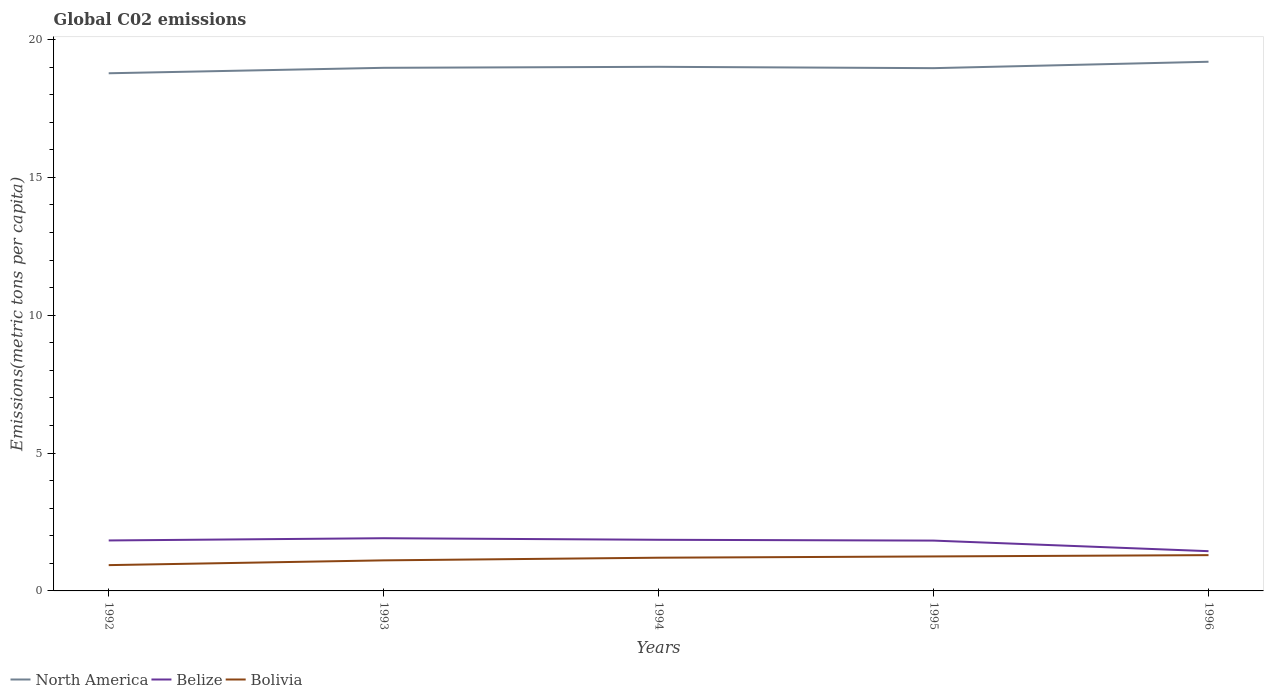How many different coloured lines are there?
Offer a terse response. 3. Does the line corresponding to North America intersect with the line corresponding to Bolivia?
Keep it short and to the point. No. Across all years, what is the maximum amount of CO2 emitted in in North America?
Your answer should be compact. 18.77. What is the total amount of CO2 emitted in in North America in the graph?
Ensure brevity in your answer.  -0.04. What is the difference between the highest and the second highest amount of CO2 emitted in in North America?
Give a very brief answer. 0.42. What is the difference between the highest and the lowest amount of CO2 emitted in in Bolivia?
Your response must be concise. 3. How many lines are there?
Ensure brevity in your answer.  3. What is the difference between two consecutive major ticks on the Y-axis?
Ensure brevity in your answer.  5. Does the graph contain any zero values?
Provide a short and direct response. No. Where does the legend appear in the graph?
Provide a succinct answer. Bottom left. How many legend labels are there?
Give a very brief answer. 3. What is the title of the graph?
Keep it short and to the point. Global C02 emissions. What is the label or title of the X-axis?
Make the answer very short. Years. What is the label or title of the Y-axis?
Offer a very short reply. Emissions(metric tons per capita). What is the Emissions(metric tons per capita) of North America in 1992?
Offer a very short reply. 18.77. What is the Emissions(metric tons per capita) of Belize in 1992?
Keep it short and to the point. 1.83. What is the Emissions(metric tons per capita) of Bolivia in 1992?
Your answer should be very brief. 0.94. What is the Emissions(metric tons per capita) in North America in 1993?
Ensure brevity in your answer.  18.97. What is the Emissions(metric tons per capita) of Belize in 1993?
Your response must be concise. 1.91. What is the Emissions(metric tons per capita) of Bolivia in 1993?
Your answer should be compact. 1.11. What is the Emissions(metric tons per capita) of North America in 1994?
Provide a short and direct response. 19.01. What is the Emissions(metric tons per capita) of Belize in 1994?
Offer a terse response. 1.85. What is the Emissions(metric tons per capita) in Bolivia in 1994?
Ensure brevity in your answer.  1.2. What is the Emissions(metric tons per capita) of North America in 1995?
Your response must be concise. 18.96. What is the Emissions(metric tons per capita) in Belize in 1995?
Make the answer very short. 1.82. What is the Emissions(metric tons per capita) in Bolivia in 1995?
Keep it short and to the point. 1.25. What is the Emissions(metric tons per capita) in North America in 1996?
Your answer should be compact. 19.19. What is the Emissions(metric tons per capita) in Belize in 1996?
Your response must be concise. 1.44. What is the Emissions(metric tons per capita) in Bolivia in 1996?
Keep it short and to the point. 1.3. Across all years, what is the maximum Emissions(metric tons per capita) in North America?
Your answer should be compact. 19.19. Across all years, what is the maximum Emissions(metric tons per capita) in Belize?
Make the answer very short. 1.91. Across all years, what is the maximum Emissions(metric tons per capita) in Bolivia?
Provide a succinct answer. 1.3. Across all years, what is the minimum Emissions(metric tons per capita) in North America?
Ensure brevity in your answer.  18.77. Across all years, what is the minimum Emissions(metric tons per capita) in Belize?
Ensure brevity in your answer.  1.44. Across all years, what is the minimum Emissions(metric tons per capita) in Bolivia?
Ensure brevity in your answer.  0.94. What is the total Emissions(metric tons per capita) in North America in the graph?
Offer a terse response. 94.9. What is the total Emissions(metric tons per capita) of Belize in the graph?
Your answer should be very brief. 8.86. What is the total Emissions(metric tons per capita) in Bolivia in the graph?
Ensure brevity in your answer.  5.8. What is the difference between the Emissions(metric tons per capita) of North America in 1992 and that in 1993?
Ensure brevity in your answer.  -0.2. What is the difference between the Emissions(metric tons per capita) of Belize in 1992 and that in 1993?
Offer a very short reply. -0.08. What is the difference between the Emissions(metric tons per capita) of Bolivia in 1992 and that in 1993?
Give a very brief answer. -0.17. What is the difference between the Emissions(metric tons per capita) of North America in 1992 and that in 1994?
Your answer should be compact. -0.23. What is the difference between the Emissions(metric tons per capita) of Belize in 1992 and that in 1994?
Give a very brief answer. -0.02. What is the difference between the Emissions(metric tons per capita) of Bolivia in 1992 and that in 1994?
Provide a succinct answer. -0.27. What is the difference between the Emissions(metric tons per capita) in North America in 1992 and that in 1995?
Ensure brevity in your answer.  -0.19. What is the difference between the Emissions(metric tons per capita) of Belize in 1992 and that in 1995?
Keep it short and to the point. 0.01. What is the difference between the Emissions(metric tons per capita) in Bolivia in 1992 and that in 1995?
Keep it short and to the point. -0.31. What is the difference between the Emissions(metric tons per capita) of North America in 1992 and that in 1996?
Your response must be concise. -0.42. What is the difference between the Emissions(metric tons per capita) in Belize in 1992 and that in 1996?
Offer a terse response. 0.39. What is the difference between the Emissions(metric tons per capita) of Bolivia in 1992 and that in 1996?
Give a very brief answer. -0.36. What is the difference between the Emissions(metric tons per capita) in North America in 1993 and that in 1994?
Provide a succinct answer. -0.04. What is the difference between the Emissions(metric tons per capita) of Belize in 1993 and that in 1994?
Provide a short and direct response. 0.06. What is the difference between the Emissions(metric tons per capita) of Bolivia in 1993 and that in 1994?
Give a very brief answer. -0.1. What is the difference between the Emissions(metric tons per capita) of North America in 1993 and that in 1995?
Your response must be concise. 0.01. What is the difference between the Emissions(metric tons per capita) in Belize in 1993 and that in 1995?
Make the answer very short. 0.09. What is the difference between the Emissions(metric tons per capita) of Bolivia in 1993 and that in 1995?
Give a very brief answer. -0.14. What is the difference between the Emissions(metric tons per capita) of North America in 1993 and that in 1996?
Offer a terse response. -0.22. What is the difference between the Emissions(metric tons per capita) of Belize in 1993 and that in 1996?
Your response must be concise. 0.47. What is the difference between the Emissions(metric tons per capita) of Bolivia in 1993 and that in 1996?
Give a very brief answer. -0.19. What is the difference between the Emissions(metric tons per capita) of North America in 1994 and that in 1995?
Your answer should be compact. 0.05. What is the difference between the Emissions(metric tons per capita) in Belize in 1994 and that in 1995?
Your answer should be compact. 0.03. What is the difference between the Emissions(metric tons per capita) in Bolivia in 1994 and that in 1995?
Ensure brevity in your answer.  -0.05. What is the difference between the Emissions(metric tons per capita) of North America in 1994 and that in 1996?
Keep it short and to the point. -0.18. What is the difference between the Emissions(metric tons per capita) of Belize in 1994 and that in 1996?
Provide a short and direct response. 0.41. What is the difference between the Emissions(metric tons per capita) of Bolivia in 1994 and that in 1996?
Your answer should be very brief. -0.09. What is the difference between the Emissions(metric tons per capita) in North America in 1995 and that in 1996?
Ensure brevity in your answer.  -0.23. What is the difference between the Emissions(metric tons per capita) of Belize in 1995 and that in 1996?
Keep it short and to the point. 0.38. What is the difference between the Emissions(metric tons per capita) in Bolivia in 1995 and that in 1996?
Give a very brief answer. -0.05. What is the difference between the Emissions(metric tons per capita) of North America in 1992 and the Emissions(metric tons per capita) of Belize in 1993?
Your response must be concise. 16.86. What is the difference between the Emissions(metric tons per capita) of North America in 1992 and the Emissions(metric tons per capita) of Bolivia in 1993?
Give a very brief answer. 17.66. What is the difference between the Emissions(metric tons per capita) in Belize in 1992 and the Emissions(metric tons per capita) in Bolivia in 1993?
Your answer should be compact. 0.72. What is the difference between the Emissions(metric tons per capita) in North America in 1992 and the Emissions(metric tons per capita) in Belize in 1994?
Ensure brevity in your answer.  16.92. What is the difference between the Emissions(metric tons per capita) in North America in 1992 and the Emissions(metric tons per capita) in Bolivia in 1994?
Give a very brief answer. 17.57. What is the difference between the Emissions(metric tons per capita) in Belize in 1992 and the Emissions(metric tons per capita) in Bolivia in 1994?
Offer a very short reply. 0.63. What is the difference between the Emissions(metric tons per capita) of North America in 1992 and the Emissions(metric tons per capita) of Belize in 1995?
Offer a terse response. 16.95. What is the difference between the Emissions(metric tons per capita) in North America in 1992 and the Emissions(metric tons per capita) in Bolivia in 1995?
Make the answer very short. 17.52. What is the difference between the Emissions(metric tons per capita) in Belize in 1992 and the Emissions(metric tons per capita) in Bolivia in 1995?
Your answer should be compact. 0.58. What is the difference between the Emissions(metric tons per capita) in North America in 1992 and the Emissions(metric tons per capita) in Belize in 1996?
Give a very brief answer. 17.33. What is the difference between the Emissions(metric tons per capita) of North America in 1992 and the Emissions(metric tons per capita) of Bolivia in 1996?
Ensure brevity in your answer.  17.48. What is the difference between the Emissions(metric tons per capita) of Belize in 1992 and the Emissions(metric tons per capita) of Bolivia in 1996?
Give a very brief answer. 0.53. What is the difference between the Emissions(metric tons per capita) of North America in 1993 and the Emissions(metric tons per capita) of Belize in 1994?
Give a very brief answer. 17.12. What is the difference between the Emissions(metric tons per capita) of North America in 1993 and the Emissions(metric tons per capita) of Bolivia in 1994?
Provide a succinct answer. 17.77. What is the difference between the Emissions(metric tons per capita) of Belize in 1993 and the Emissions(metric tons per capita) of Bolivia in 1994?
Make the answer very short. 0.71. What is the difference between the Emissions(metric tons per capita) of North America in 1993 and the Emissions(metric tons per capita) of Belize in 1995?
Your answer should be compact. 17.15. What is the difference between the Emissions(metric tons per capita) in North America in 1993 and the Emissions(metric tons per capita) in Bolivia in 1995?
Your response must be concise. 17.72. What is the difference between the Emissions(metric tons per capita) in Belize in 1993 and the Emissions(metric tons per capita) in Bolivia in 1995?
Offer a terse response. 0.66. What is the difference between the Emissions(metric tons per capita) in North America in 1993 and the Emissions(metric tons per capita) in Belize in 1996?
Make the answer very short. 17.53. What is the difference between the Emissions(metric tons per capita) in North America in 1993 and the Emissions(metric tons per capita) in Bolivia in 1996?
Provide a short and direct response. 17.67. What is the difference between the Emissions(metric tons per capita) in Belize in 1993 and the Emissions(metric tons per capita) in Bolivia in 1996?
Offer a terse response. 0.61. What is the difference between the Emissions(metric tons per capita) of North America in 1994 and the Emissions(metric tons per capita) of Belize in 1995?
Provide a short and direct response. 17.18. What is the difference between the Emissions(metric tons per capita) in North America in 1994 and the Emissions(metric tons per capita) in Bolivia in 1995?
Ensure brevity in your answer.  17.76. What is the difference between the Emissions(metric tons per capita) of Belize in 1994 and the Emissions(metric tons per capita) of Bolivia in 1995?
Offer a very short reply. 0.6. What is the difference between the Emissions(metric tons per capita) of North America in 1994 and the Emissions(metric tons per capita) of Belize in 1996?
Provide a short and direct response. 17.57. What is the difference between the Emissions(metric tons per capita) of North America in 1994 and the Emissions(metric tons per capita) of Bolivia in 1996?
Your response must be concise. 17.71. What is the difference between the Emissions(metric tons per capita) of Belize in 1994 and the Emissions(metric tons per capita) of Bolivia in 1996?
Offer a terse response. 0.56. What is the difference between the Emissions(metric tons per capita) of North America in 1995 and the Emissions(metric tons per capita) of Belize in 1996?
Offer a very short reply. 17.52. What is the difference between the Emissions(metric tons per capita) of North America in 1995 and the Emissions(metric tons per capita) of Bolivia in 1996?
Keep it short and to the point. 17.66. What is the difference between the Emissions(metric tons per capita) of Belize in 1995 and the Emissions(metric tons per capita) of Bolivia in 1996?
Offer a very short reply. 0.53. What is the average Emissions(metric tons per capita) of North America per year?
Make the answer very short. 18.98. What is the average Emissions(metric tons per capita) of Belize per year?
Make the answer very short. 1.77. What is the average Emissions(metric tons per capita) of Bolivia per year?
Your response must be concise. 1.16. In the year 1992, what is the difference between the Emissions(metric tons per capita) of North America and Emissions(metric tons per capita) of Belize?
Make the answer very short. 16.94. In the year 1992, what is the difference between the Emissions(metric tons per capita) of North America and Emissions(metric tons per capita) of Bolivia?
Provide a succinct answer. 17.84. In the year 1992, what is the difference between the Emissions(metric tons per capita) of Belize and Emissions(metric tons per capita) of Bolivia?
Your answer should be very brief. 0.89. In the year 1993, what is the difference between the Emissions(metric tons per capita) of North America and Emissions(metric tons per capita) of Belize?
Provide a short and direct response. 17.06. In the year 1993, what is the difference between the Emissions(metric tons per capita) of North America and Emissions(metric tons per capita) of Bolivia?
Provide a short and direct response. 17.86. In the year 1993, what is the difference between the Emissions(metric tons per capita) of Belize and Emissions(metric tons per capita) of Bolivia?
Ensure brevity in your answer.  0.8. In the year 1994, what is the difference between the Emissions(metric tons per capita) in North America and Emissions(metric tons per capita) in Belize?
Offer a terse response. 17.15. In the year 1994, what is the difference between the Emissions(metric tons per capita) in North America and Emissions(metric tons per capita) in Bolivia?
Provide a short and direct response. 17.8. In the year 1994, what is the difference between the Emissions(metric tons per capita) in Belize and Emissions(metric tons per capita) in Bolivia?
Make the answer very short. 0.65. In the year 1995, what is the difference between the Emissions(metric tons per capita) in North America and Emissions(metric tons per capita) in Belize?
Offer a very short reply. 17.13. In the year 1995, what is the difference between the Emissions(metric tons per capita) in North America and Emissions(metric tons per capita) in Bolivia?
Keep it short and to the point. 17.71. In the year 1995, what is the difference between the Emissions(metric tons per capita) in Belize and Emissions(metric tons per capita) in Bolivia?
Provide a succinct answer. 0.57. In the year 1996, what is the difference between the Emissions(metric tons per capita) of North America and Emissions(metric tons per capita) of Belize?
Keep it short and to the point. 17.75. In the year 1996, what is the difference between the Emissions(metric tons per capita) in North America and Emissions(metric tons per capita) in Bolivia?
Offer a very short reply. 17.89. In the year 1996, what is the difference between the Emissions(metric tons per capita) in Belize and Emissions(metric tons per capita) in Bolivia?
Provide a succinct answer. 0.14. What is the ratio of the Emissions(metric tons per capita) in Belize in 1992 to that in 1993?
Your answer should be very brief. 0.96. What is the ratio of the Emissions(metric tons per capita) of Bolivia in 1992 to that in 1993?
Your answer should be compact. 0.84. What is the ratio of the Emissions(metric tons per capita) in North America in 1992 to that in 1994?
Keep it short and to the point. 0.99. What is the ratio of the Emissions(metric tons per capita) of Bolivia in 1992 to that in 1994?
Keep it short and to the point. 0.78. What is the ratio of the Emissions(metric tons per capita) of North America in 1992 to that in 1995?
Your answer should be compact. 0.99. What is the ratio of the Emissions(metric tons per capita) of Belize in 1992 to that in 1995?
Make the answer very short. 1. What is the ratio of the Emissions(metric tons per capita) in Bolivia in 1992 to that in 1995?
Ensure brevity in your answer.  0.75. What is the ratio of the Emissions(metric tons per capita) of North America in 1992 to that in 1996?
Give a very brief answer. 0.98. What is the ratio of the Emissions(metric tons per capita) in Belize in 1992 to that in 1996?
Give a very brief answer. 1.27. What is the ratio of the Emissions(metric tons per capita) of Bolivia in 1992 to that in 1996?
Provide a short and direct response. 0.72. What is the ratio of the Emissions(metric tons per capita) of Belize in 1993 to that in 1994?
Keep it short and to the point. 1.03. What is the ratio of the Emissions(metric tons per capita) in Bolivia in 1993 to that in 1994?
Offer a very short reply. 0.92. What is the ratio of the Emissions(metric tons per capita) in Belize in 1993 to that in 1995?
Keep it short and to the point. 1.05. What is the ratio of the Emissions(metric tons per capita) in Bolivia in 1993 to that in 1995?
Your answer should be very brief. 0.89. What is the ratio of the Emissions(metric tons per capita) in North America in 1993 to that in 1996?
Ensure brevity in your answer.  0.99. What is the ratio of the Emissions(metric tons per capita) in Belize in 1993 to that in 1996?
Provide a succinct answer. 1.33. What is the ratio of the Emissions(metric tons per capita) of Bolivia in 1993 to that in 1996?
Your answer should be very brief. 0.85. What is the ratio of the Emissions(metric tons per capita) of North America in 1994 to that in 1995?
Make the answer very short. 1. What is the ratio of the Emissions(metric tons per capita) in Belize in 1994 to that in 1995?
Give a very brief answer. 1.02. What is the ratio of the Emissions(metric tons per capita) in Bolivia in 1994 to that in 1995?
Offer a terse response. 0.96. What is the ratio of the Emissions(metric tons per capita) in Belize in 1994 to that in 1996?
Offer a very short reply. 1.29. What is the ratio of the Emissions(metric tons per capita) in Bolivia in 1994 to that in 1996?
Your answer should be compact. 0.93. What is the ratio of the Emissions(metric tons per capita) in North America in 1995 to that in 1996?
Offer a terse response. 0.99. What is the ratio of the Emissions(metric tons per capita) in Belize in 1995 to that in 1996?
Make the answer very short. 1.27. What is the ratio of the Emissions(metric tons per capita) of Bolivia in 1995 to that in 1996?
Offer a terse response. 0.96. What is the difference between the highest and the second highest Emissions(metric tons per capita) of North America?
Your answer should be compact. 0.18. What is the difference between the highest and the second highest Emissions(metric tons per capita) of Belize?
Ensure brevity in your answer.  0.06. What is the difference between the highest and the second highest Emissions(metric tons per capita) in Bolivia?
Keep it short and to the point. 0.05. What is the difference between the highest and the lowest Emissions(metric tons per capita) in North America?
Keep it short and to the point. 0.42. What is the difference between the highest and the lowest Emissions(metric tons per capita) of Belize?
Make the answer very short. 0.47. What is the difference between the highest and the lowest Emissions(metric tons per capita) of Bolivia?
Make the answer very short. 0.36. 